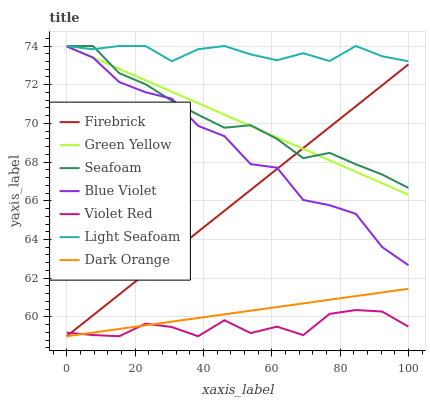Does Violet Red have the minimum area under the curve?
Answer yes or no. Yes. Does Light Seafoam have the maximum area under the curve?
Answer yes or no. Yes. Does Green Yellow have the minimum area under the curve?
Answer yes or no. No. Does Green Yellow have the maximum area under the curve?
Answer yes or no. No. Is Dark Orange the smoothest?
Answer yes or no. Yes. Is Blue Violet the roughest?
Answer yes or no. Yes. Is Violet Red the smoothest?
Answer yes or no. No. Is Violet Red the roughest?
Answer yes or no. No. Does Green Yellow have the lowest value?
Answer yes or no. No. Does Light Seafoam have the highest value?
Answer yes or no. Yes. Does Violet Red have the highest value?
Answer yes or no. No. Is Violet Red less than Blue Violet?
Answer yes or no. Yes. Is Light Seafoam greater than Firebrick?
Answer yes or no. Yes. Does Violet Red intersect Blue Violet?
Answer yes or no. No. 